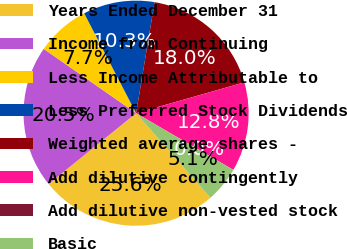<chart> <loc_0><loc_0><loc_500><loc_500><pie_chart><fcel>Years Ended December 31<fcel>Income from Continuing<fcel>Less Income Attributable to<fcel>Less Preferred Stock Dividends<fcel>Weighted average shares -<fcel>Add dilutive contingently<fcel>Add dilutive non-vested stock<fcel>Basic<nl><fcel>25.64%<fcel>20.51%<fcel>7.69%<fcel>10.26%<fcel>17.95%<fcel>12.82%<fcel>0.0%<fcel>5.13%<nl></chart> 